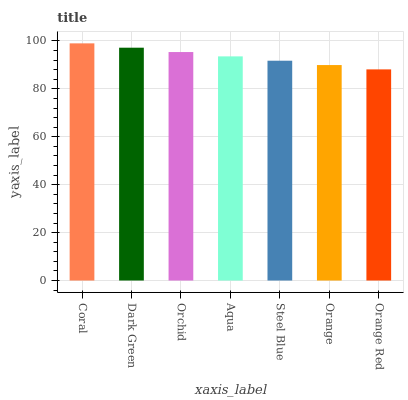Is Dark Green the minimum?
Answer yes or no. No. Is Dark Green the maximum?
Answer yes or no. No. Is Coral greater than Dark Green?
Answer yes or no. Yes. Is Dark Green less than Coral?
Answer yes or no. Yes. Is Dark Green greater than Coral?
Answer yes or no. No. Is Coral less than Dark Green?
Answer yes or no. No. Is Aqua the high median?
Answer yes or no. Yes. Is Aqua the low median?
Answer yes or no. Yes. Is Coral the high median?
Answer yes or no. No. Is Orchid the low median?
Answer yes or no. No. 